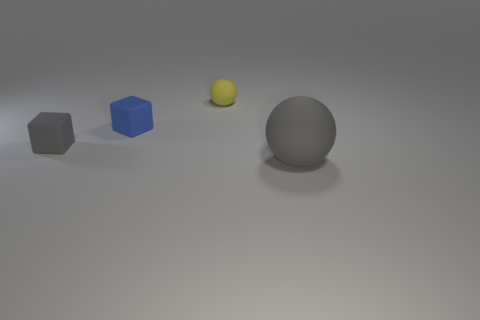Add 2 cubes. How many objects exist? 6 Subtract 0 purple cubes. How many objects are left? 4 Subtract all small purple shiny balls. Subtract all blue blocks. How many objects are left? 3 Add 4 small yellow balls. How many small yellow balls are left? 5 Add 3 gray balls. How many gray balls exist? 4 